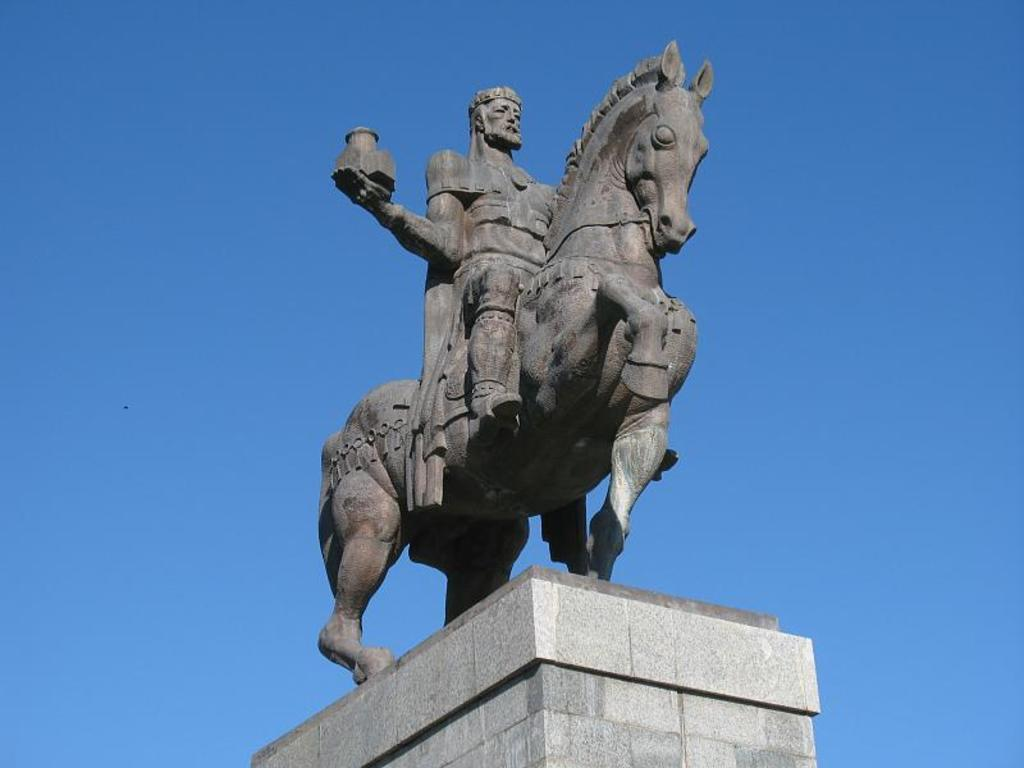What is the main subject of the image? There is a statue of a person in the image. What other elements are included in the statue? The statue includes a horse. What can be seen in the background of the image? The sky is visible in the image. Can you tell me how many tigers are sitting on the rock next to the statue? There are no tigers or rocks present in the image; it features a statue of a person and a horse. What type of trick is the statue performing in the image? The statue is not performing any tricks; it is a stationary representation of a person and a horse. 